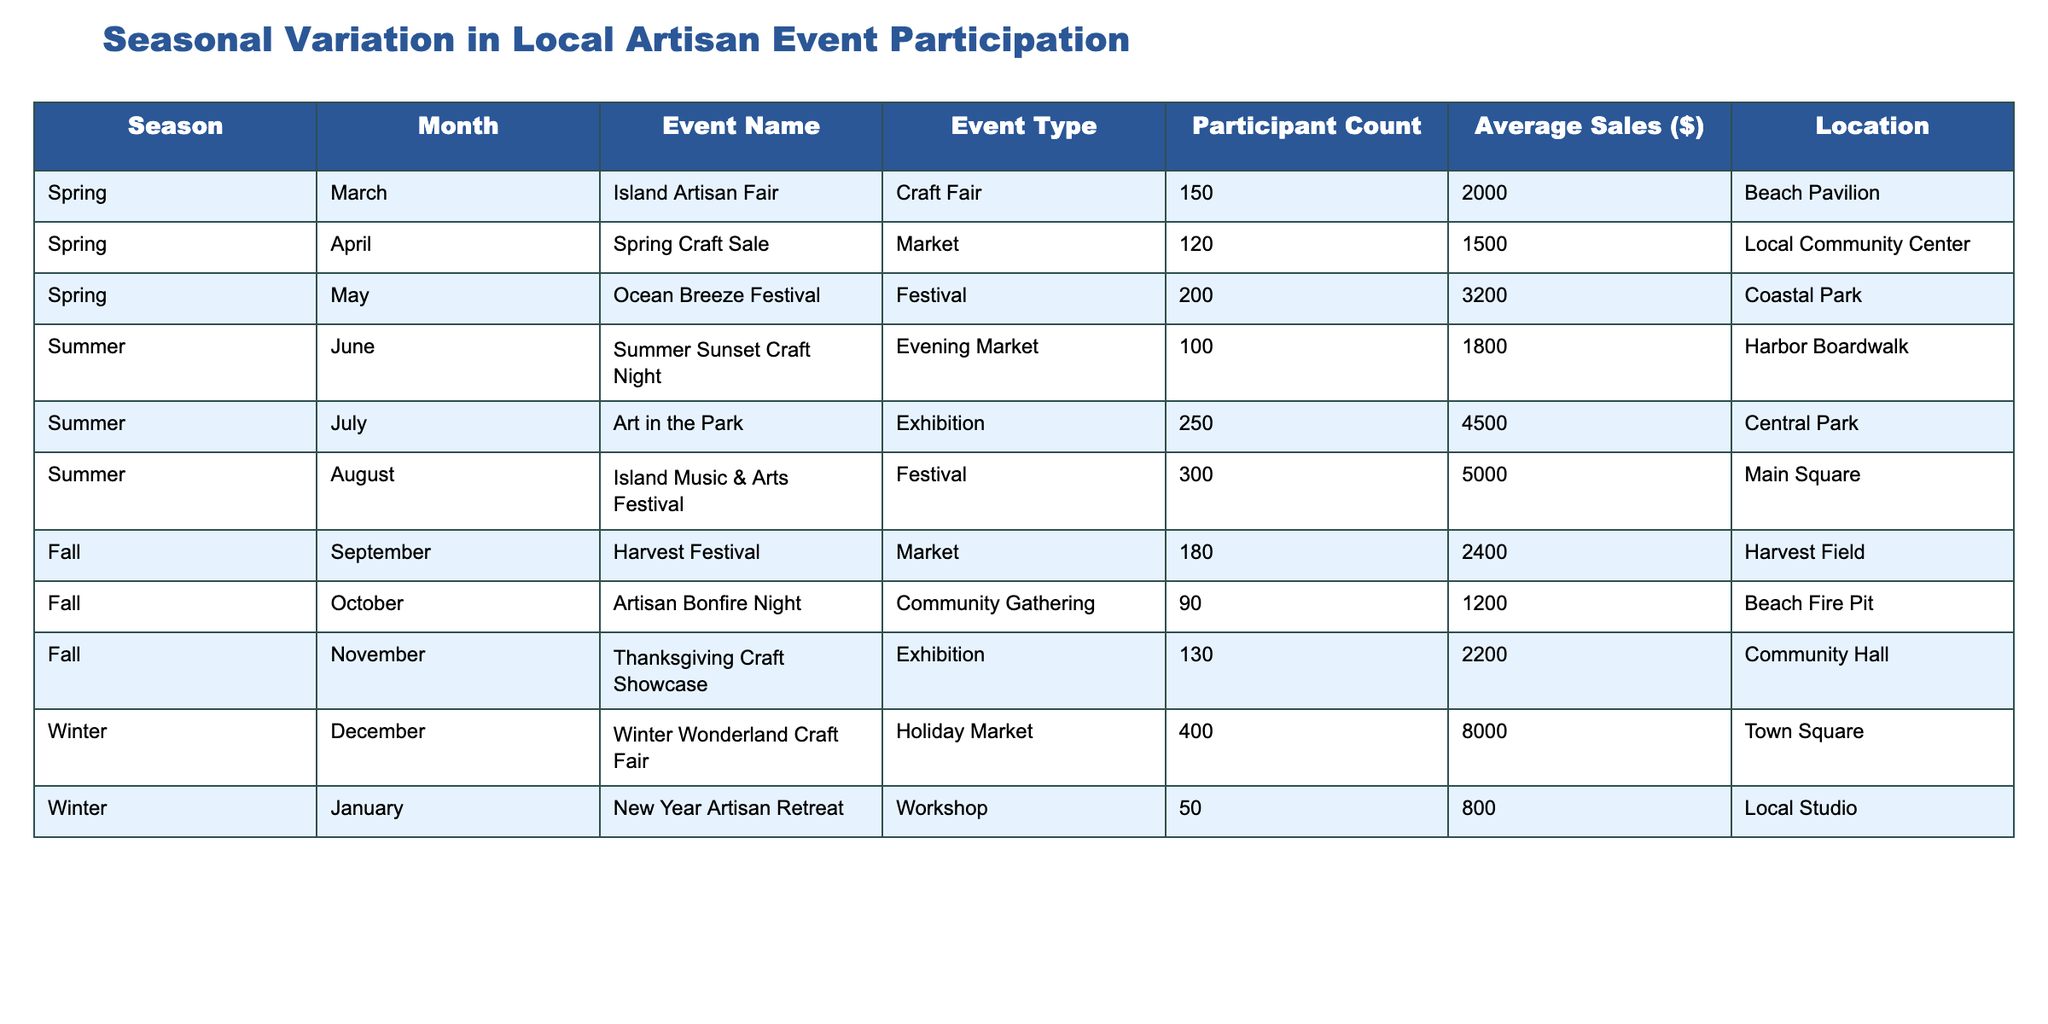How many participants attended the Ocean Breeze Festival? The Ocean Breeze Festival is listed in the table under Spring for the month of May. The participant count for this event is directly mentioned in the table as 200.
Answer: 200 What was the average sales amount for events held in Summer? To find the average sales for Summer events, we need to sum the average sales values for June, July, and August: 1800 + 4500 + 5000 = 11300. Then, since there are 3 events, we calculate the average by dividing 11300 by 3, resulting in approximately 3766.67.
Answer: 3766.67 Did the Artisan Bonfire Night have more participants than the New Year Artisan Retreat? The participant count for the Artisan Bonfire Night is 90 while for the New Year Artisan Retreat, it is 50. Since 90 is greater than 50, the answer is yes.
Answer: Yes Which event had the highest participant count and how many participants did it attract? By inspecting the table, the event with the highest participant count is the Winter Wonderland Craft Fair in December, which had 400 participants. This is the maximum value in the participant count column.
Answer: 400 What is the total participant count for all events in Fall? To find the total participant count for Fall, we need to sum the participant counts for each Fall event listed: September (180) + October (90) + November (130) = 400. The total for the Fall events is therefore 400.
Answer: 400 Is the average sales amount for the Island Artisan Fair higher than the average sales for the Thanksgiving Craft Showcase? The average sales for the Island Artisan Fair is $2000, while for the Thanksgiving Craft Showcase, it is $2200. Since 2000 is less than 2200, the answer is no.
Answer: No How many events were held in Spring, and what was the total sales for those events? There are three events listed in Spring: March (2000), April (1500), and May (3200). To find the total sales, we add these values: 2000 + 1500 + 3200 = 6700. Thus, there were 3 Spring events with total sales of 6700.
Answer: 3 events, 6700 sales What is the difference between the participant count of the Summer Sunset Craft Night and the Ocean Breeze Festival? The participant count for the Summer Sunset Craft Night is 100, and for the Ocean Breeze Festival, it is 200. The difference is calculated as 200 - 100 = 100.
Answer: 100 